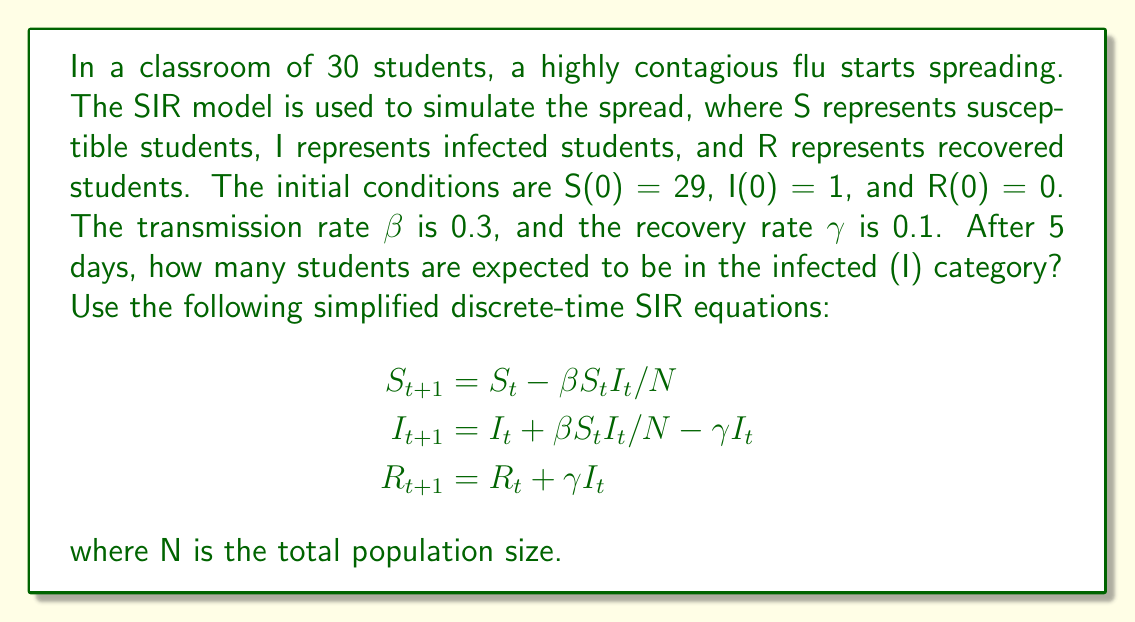What is the answer to this math problem? Let's solve this problem step-by-step using the given discrete-time SIR equations:

1. Initialize the variables:
   N = 30 (total students)
   S₀ = 29, I₀ = 1, R₀ = 0
   β = 0.3, γ = 0.1

2. Calculate for each day (t = 0 to 4):

   Day 0:
   S₀ = 29, I₀ = 1, R₀ = 0

   Day 1:
   S₁ = S₀ - βS₀I₀/N = 29 - 0.3 * 29 * 1 / 30 = 28.71
   I₁ = I₀ + βS₀I₀/N - γI₀ = 1 + 0.3 * 29 * 1 / 30 - 0.1 * 1 = 1.19
   R₁ = R₀ + γI₀ = 0 + 0.1 * 1 = 0.1

   Day 2:
   S₂ = 28.71 - 0.3 * 28.71 * 1.19 / 30 = 28.37
   I₂ = 1.19 + 0.3 * 28.71 * 1.19 / 30 - 0.1 * 1.19 = 1.41
   R₂ = 0.1 + 0.1 * 1.19 = 0.22

   Day 3:
   S₃ = 28.37 - 0.3 * 28.37 * 1.41 / 30 = 27.97
   I₃ = 1.41 + 0.3 * 28.37 * 1.41 / 30 - 0.1 * 1.41 = 1.67
   R₃ = 0.22 + 0.1 * 1.41 = 0.36

   Day 4:
   S₄ = 27.97 - 0.3 * 27.97 * 1.67 / 30 = 27.51
   I₄ = 1.67 + 0.3 * 27.97 * 1.67 / 30 - 0.1 * 1.67 = 1.96
   R₄ = 0.36 + 0.1 * 1.67 = 0.53

   Day 5 (final result):
   S₅ = 27.51 - 0.3 * 27.51 * 1.96 / 30 = 26.98
   I₅ = 1.96 + 0.3 * 27.51 * 1.96 / 30 - 0.1 * 1.96 = 2.29
   R₅ = 0.53 + 0.1 * 1.96 = 0.73

3. The number of infected students after 5 days is I₅ = 2.29.

4. Since we're dealing with whole students, we round to the nearest integer: 2 students.
Answer: 2 students 